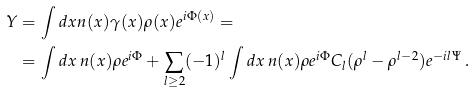<formula> <loc_0><loc_0><loc_500><loc_500>Y & = \int d x n ( x ) \gamma ( x ) \rho ( x ) e ^ { i \Phi ( x ) } = \\ & = \int d x \, n ( x ) \rho e ^ { i \Phi } + \sum _ { l \geq 2 } ( - 1 ) ^ { l } \int d x \, n ( x ) \rho e ^ { i \Phi } C _ { l } ( \rho ^ { l } - \rho ^ { l - 2 } ) e ^ { - i l \Psi } \, .</formula> 